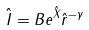Convert formula to latex. <formula><loc_0><loc_0><loc_500><loc_500>\hat { I } = B e ^ { \hat { X } } \hat { r } ^ { - \gamma }</formula> 